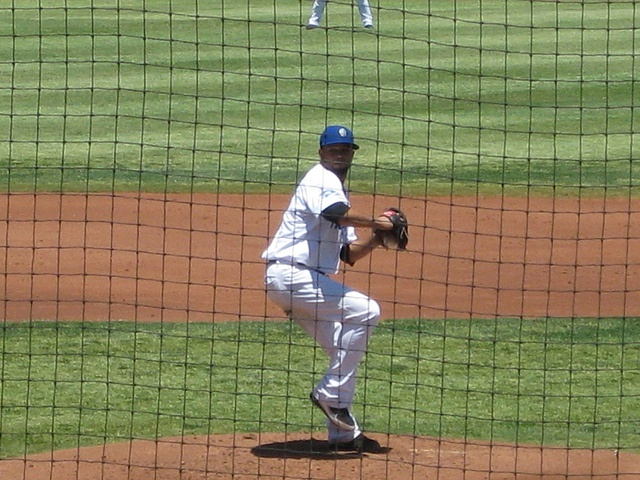Describe the objects in this image and their specific colors. I can see people in olive, gray, white, and black tones, baseball glove in olive, black, gray, and maroon tones, people in olive, lightgray, gray, and darkgray tones, and sports ball in olive, black, maroon, and gray tones in this image. 